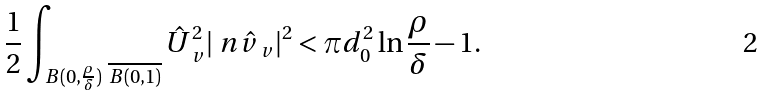<formula> <loc_0><loc_0><loc_500><loc_500>\frac { 1 } { 2 } \int _ { B ( 0 , \frac { \rho } { \delta } ) \ \overline { B ( 0 , 1 ) } } { \hat { U } _ { \ v } ^ { 2 } | \ n \hat { v } _ { \ v } | ^ { 2 } } < \pi d _ { 0 } ^ { 2 } \ln \frac { \rho } { \delta } - 1 .</formula> 